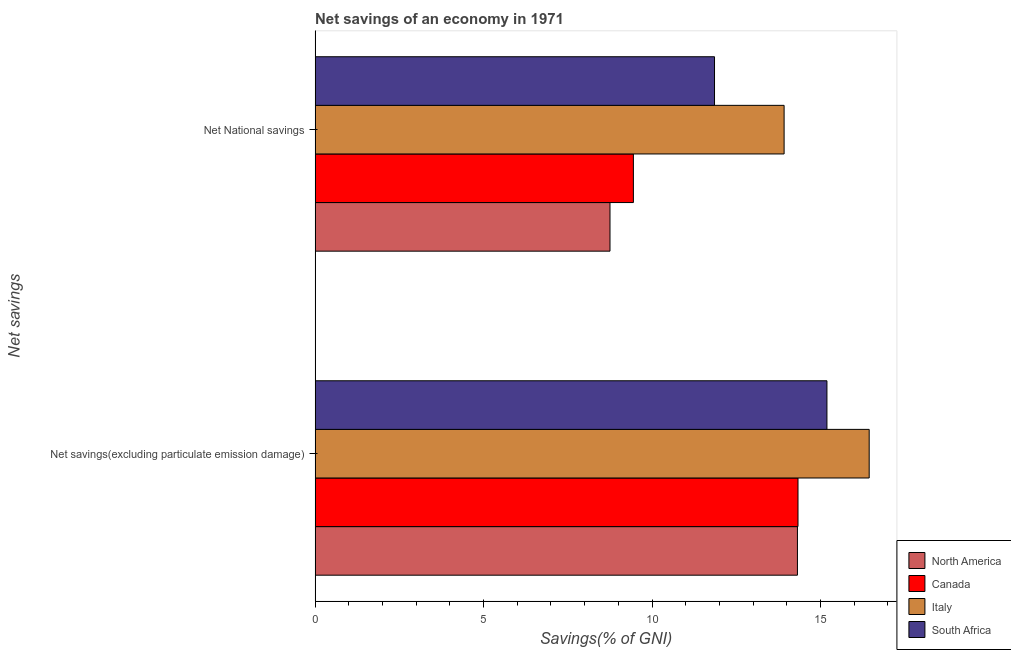Are the number of bars per tick equal to the number of legend labels?
Make the answer very short. Yes. What is the label of the 1st group of bars from the top?
Your answer should be compact. Net National savings. What is the net national savings in Italy?
Make the answer very short. 13.92. Across all countries, what is the maximum net national savings?
Your answer should be very brief. 13.92. Across all countries, what is the minimum net national savings?
Give a very brief answer. 8.75. In which country was the net national savings maximum?
Provide a short and direct response. Italy. What is the total net national savings in the graph?
Your answer should be very brief. 43.97. What is the difference between the net national savings in South Africa and that in Italy?
Offer a terse response. -2.07. What is the difference between the net savings(excluding particulate emission damage) in South Africa and the net national savings in Canada?
Your answer should be very brief. 5.74. What is the average net national savings per country?
Ensure brevity in your answer.  10.99. What is the difference between the net savings(excluding particulate emission damage) and net national savings in North America?
Offer a terse response. 5.56. In how many countries, is the net savings(excluding particulate emission damage) greater than 10 %?
Provide a succinct answer. 4. What is the ratio of the net savings(excluding particulate emission damage) in South Africa to that in North America?
Give a very brief answer. 1.06. Is the net national savings in Canada less than that in South Africa?
Keep it short and to the point. Yes. What does the 1st bar from the top in Net savings(excluding particulate emission damage) represents?
Ensure brevity in your answer.  South Africa. What does the 4th bar from the bottom in Net National savings represents?
Make the answer very short. South Africa. How many bars are there?
Provide a short and direct response. 8. How many countries are there in the graph?
Your response must be concise. 4. What is the difference between two consecutive major ticks on the X-axis?
Your response must be concise. 5. Does the graph contain any zero values?
Make the answer very short. No. Does the graph contain grids?
Your answer should be compact. No. Where does the legend appear in the graph?
Your answer should be very brief. Bottom right. How are the legend labels stacked?
Provide a short and direct response. Vertical. What is the title of the graph?
Give a very brief answer. Net savings of an economy in 1971. What is the label or title of the X-axis?
Keep it short and to the point. Savings(% of GNI). What is the label or title of the Y-axis?
Offer a terse response. Net savings. What is the Savings(% of GNI) in North America in Net savings(excluding particulate emission damage)?
Give a very brief answer. 14.31. What is the Savings(% of GNI) of Canada in Net savings(excluding particulate emission damage)?
Your response must be concise. 14.33. What is the Savings(% of GNI) in Italy in Net savings(excluding particulate emission damage)?
Your answer should be compact. 16.44. What is the Savings(% of GNI) of South Africa in Net savings(excluding particulate emission damage)?
Offer a very short reply. 15.19. What is the Savings(% of GNI) of North America in Net National savings?
Offer a very short reply. 8.75. What is the Savings(% of GNI) of Canada in Net National savings?
Your answer should be very brief. 9.45. What is the Savings(% of GNI) in Italy in Net National savings?
Keep it short and to the point. 13.92. What is the Savings(% of GNI) of South Africa in Net National savings?
Provide a succinct answer. 11.85. Across all Net savings, what is the maximum Savings(% of GNI) in North America?
Ensure brevity in your answer.  14.31. Across all Net savings, what is the maximum Savings(% of GNI) in Canada?
Your response must be concise. 14.33. Across all Net savings, what is the maximum Savings(% of GNI) of Italy?
Offer a very short reply. 16.44. Across all Net savings, what is the maximum Savings(% of GNI) of South Africa?
Ensure brevity in your answer.  15.19. Across all Net savings, what is the minimum Savings(% of GNI) in North America?
Ensure brevity in your answer.  8.75. Across all Net savings, what is the minimum Savings(% of GNI) of Canada?
Your answer should be very brief. 9.45. Across all Net savings, what is the minimum Savings(% of GNI) in Italy?
Give a very brief answer. 13.92. Across all Net savings, what is the minimum Savings(% of GNI) in South Africa?
Offer a terse response. 11.85. What is the total Savings(% of GNI) in North America in the graph?
Make the answer very short. 23.07. What is the total Savings(% of GNI) of Canada in the graph?
Ensure brevity in your answer.  23.78. What is the total Savings(% of GNI) of Italy in the graph?
Offer a very short reply. 30.36. What is the total Savings(% of GNI) of South Africa in the graph?
Make the answer very short. 27.04. What is the difference between the Savings(% of GNI) in North America in Net savings(excluding particulate emission damage) and that in Net National savings?
Ensure brevity in your answer.  5.56. What is the difference between the Savings(% of GNI) of Canada in Net savings(excluding particulate emission damage) and that in Net National savings?
Offer a very short reply. 4.89. What is the difference between the Savings(% of GNI) in Italy in Net savings(excluding particulate emission damage) and that in Net National savings?
Make the answer very short. 2.53. What is the difference between the Savings(% of GNI) in South Africa in Net savings(excluding particulate emission damage) and that in Net National savings?
Keep it short and to the point. 3.34. What is the difference between the Savings(% of GNI) in North America in Net savings(excluding particulate emission damage) and the Savings(% of GNI) in Canada in Net National savings?
Make the answer very short. 4.87. What is the difference between the Savings(% of GNI) of North America in Net savings(excluding particulate emission damage) and the Savings(% of GNI) of Italy in Net National savings?
Your answer should be compact. 0.4. What is the difference between the Savings(% of GNI) of North America in Net savings(excluding particulate emission damage) and the Savings(% of GNI) of South Africa in Net National savings?
Your answer should be compact. 2.46. What is the difference between the Savings(% of GNI) of Canada in Net savings(excluding particulate emission damage) and the Savings(% of GNI) of Italy in Net National savings?
Ensure brevity in your answer.  0.41. What is the difference between the Savings(% of GNI) of Canada in Net savings(excluding particulate emission damage) and the Savings(% of GNI) of South Africa in Net National savings?
Ensure brevity in your answer.  2.48. What is the difference between the Savings(% of GNI) in Italy in Net savings(excluding particulate emission damage) and the Savings(% of GNI) in South Africa in Net National savings?
Your response must be concise. 4.59. What is the average Savings(% of GNI) of North America per Net savings?
Offer a very short reply. 11.53. What is the average Savings(% of GNI) of Canada per Net savings?
Keep it short and to the point. 11.89. What is the average Savings(% of GNI) of Italy per Net savings?
Ensure brevity in your answer.  15.18. What is the average Savings(% of GNI) of South Africa per Net savings?
Offer a terse response. 13.52. What is the difference between the Savings(% of GNI) in North America and Savings(% of GNI) in Canada in Net savings(excluding particulate emission damage)?
Make the answer very short. -0.02. What is the difference between the Savings(% of GNI) of North America and Savings(% of GNI) of Italy in Net savings(excluding particulate emission damage)?
Keep it short and to the point. -2.13. What is the difference between the Savings(% of GNI) of North America and Savings(% of GNI) of South Africa in Net savings(excluding particulate emission damage)?
Your response must be concise. -0.88. What is the difference between the Savings(% of GNI) in Canada and Savings(% of GNI) in Italy in Net savings(excluding particulate emission damage)?
Make the answer very short. -2.11. What is the difference between the Savings(% of GNI) in Canada and Savings(% of GNI) in South Africa in Net savings(excluding particulate emission damage)?
Your response must be concise. -0.86. What is the difference between the Savings(% of GNI) of Italy and Savings(% of GNI) of South Africa in Net savings(excluding particulate emission damage)?
Provide a succinct answer. 1.25. What is the difference between the Savings(% of GNI) of North America and Savings(% of GNI) of Canada in Net National savings?
Make the answer very short. -0.69. What is the difference between the Savings(% of GNI) of North America and Savings(% of GNI) of Italy in Net National savings?
Your answer should be very brief. -5.17. What is the difference between the Savings(% of GNI) of North America and Savings(% of GNI) of South Africa in Net National savings?
Your answer should be very brief. -3.1. What is the difference between the Savings(% of GNI) of Canada and Savings(% of GNI) of Italy in Net National savings?
Make the answer very short. -4.47. What is the difference between the Savings(% of GNI) in Canada and Savings(% of GNI) in South Africa in Net National savings?
Your answer should be very brief. -2.41. What is the difference between the Savings(% of GNI) of Italy and Savings(% of GNI) of South Africa in Net National savings?
Make the answer very short. 2.07. What is the ratio of the Savings(% of GNI) of North America in Net savings(excluding particulate emission damage) to that in Net National savings?
Your answer should be very brief. 1.64. What is the ratio of the Savings(% of GNI) of Canada in Net savings(excluding particulate emission damage) to that in Net National savings?
Give a very brief answer. 1.52. What is the ratio of the Savings(% of GNI) of Italy in Net savings(excluding particulate emission damage) to that in Net National savings?
Offer a very short reply. 1.18. What is the ratio of the Savings(% of GNI) of South Africa in Net savings(excluding particulate emission damage) to that in Net National savings?
Offer a terse response. 1.28. What is the difference between the highest and the second highest Savings(% of GNI) in North America?
Provide a short and direct response. 5.56. What is the difference between the highest and the second highest Savings(% of GNI) in Canada?
Your response must be concise. 4.89. What is the difference between the highest and the second highest Savings(% of GNI) in Italy?
Offer a very short reply. 2.53. What is the difference between the highest and the second highest Savings(% of GNI) in South Africa?
Offer a very short reply. 3.34. What is the difference between the highest and the lowest Savings(% of GNI) in North America?
Offer a terse response. 5.56. What is the difference between the highest and the lowest Savings(% of GNI) of Canada?
Keep it short and to the point. 4.89. What is the difference between the highest and the lowest Savings(% of GNI) of Italy?
Provide a short and direct response. 2.53. What is the difference between the highest and the lowest Savings(% of GNI) in South Africa?
Offer a very short reply. 3.34. 